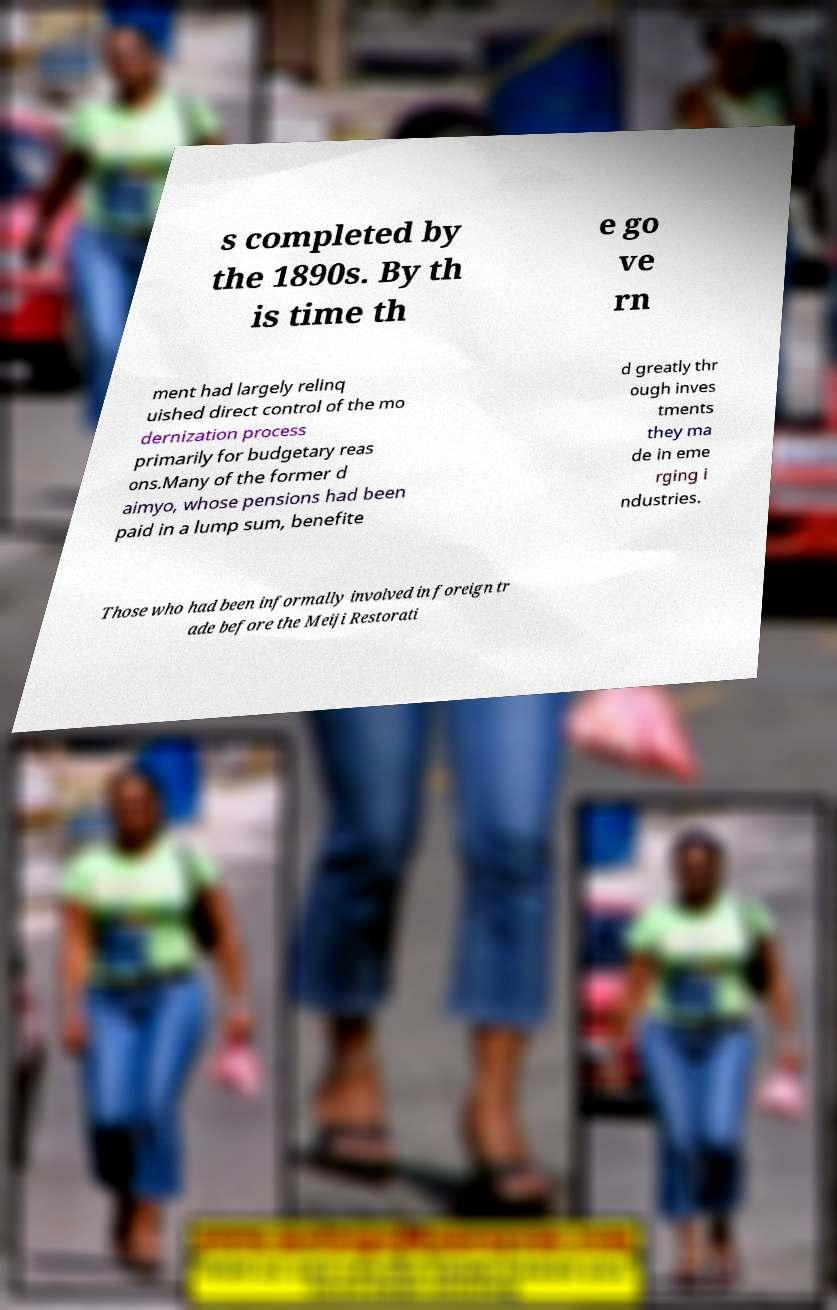There's text embedded in this image that I need extracted. Can you transcribe it verbatim? s completed by the 1890s. By th is time th e go ve rn ment had largely relinq uished direct control of the mo dernization process primarily for budgetary reas ons.Many of the former d aimyo, whose pensions had been paid in a lump sum, benefite d greatly thr ough inves tments they ma de in eme rging i ndustries. Those who had been informally involved in foreign tr ade before the Meiji Restorati 